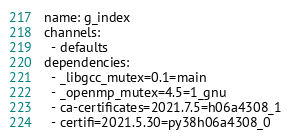<code> <loc_0><loc_0><loc_500><loc_500><_YAML_>name: g_index
channels:
  - defaults
dependencies:
  - _libgcc_mutex=0.1=main
  - _openmp_mutex=4.5=1_gnu
  - ca-certificates=2021.7.5=h06a4308_1
  - certifi=2021.5.30=py38h06a4308_0</code> 